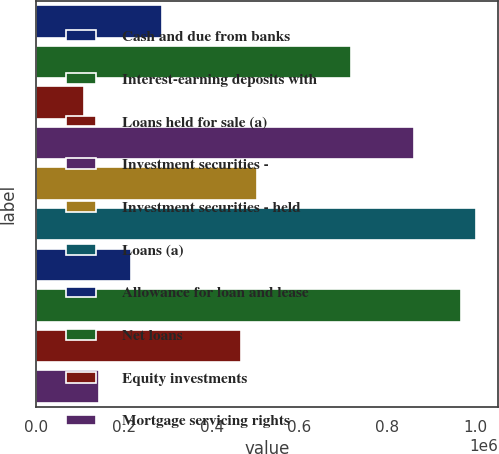<chart> <loc_0><loc_0><loc_500><loc_500><bar_chart><fcel>Cash and due from banks<fcel>Interest-earning deposits with<fcel>Loans held for sale (a)<fcel>Investment securities -<fcel>Investment securities - held<fcel>Loans (a)<fcel>Allowance for loan and lease<fcel>Net loans<fcel>Equity investments<fcel>Mortgage servicing rights<nl><fcel>286820<fcel>716856<fcel>107639<fcel>860201<fcel>501838<fcel>1.00355e+06<fcel>215148<fcel>967710<fcel>466002<fcel>143475<nl></chart> 